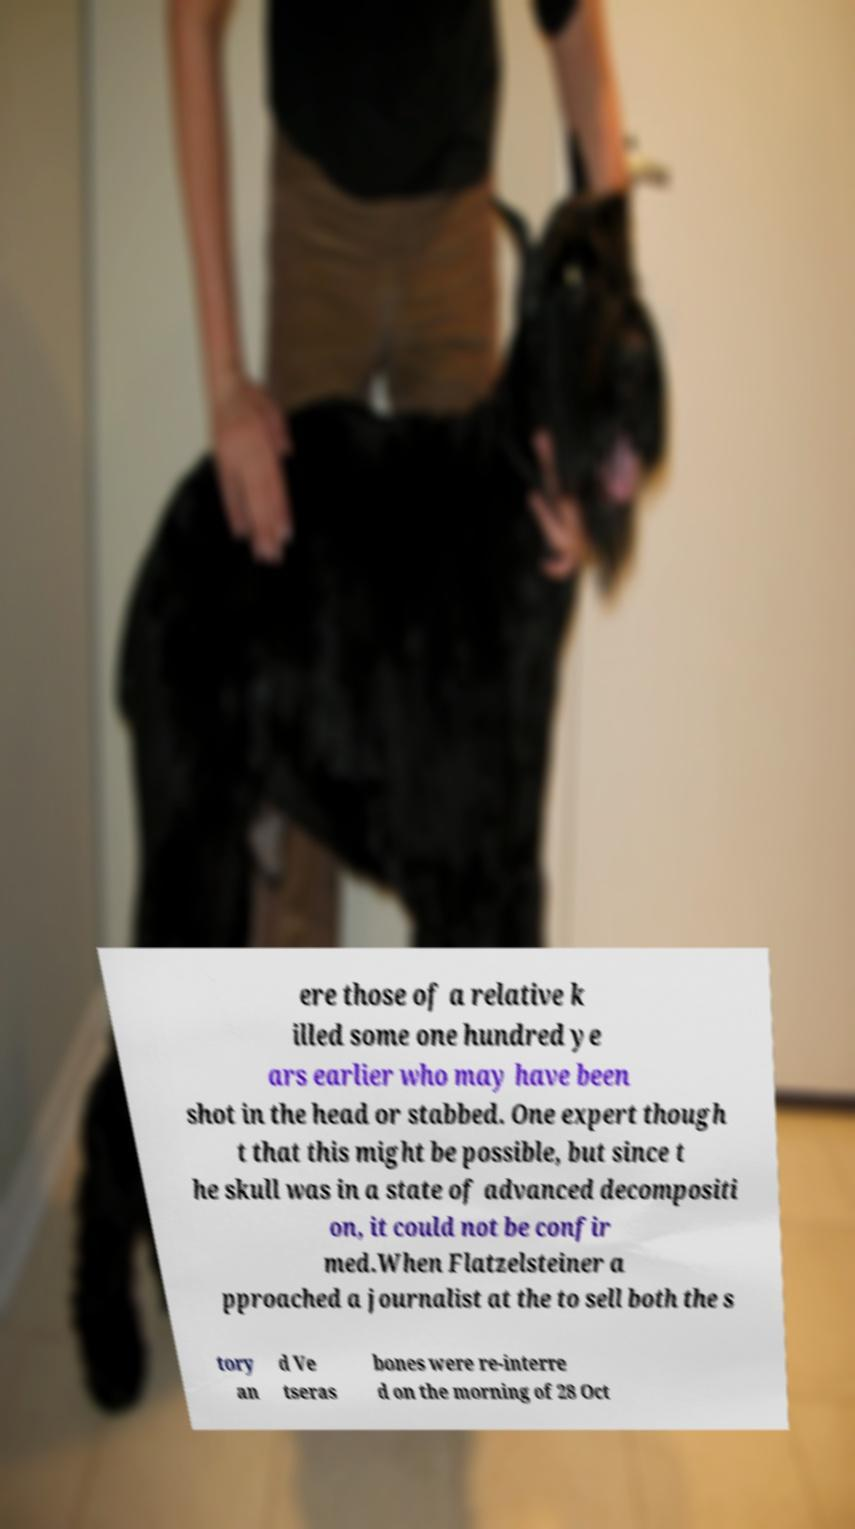Could you assist in decoding the text presented in this image and type it out clearly? ere those of a relative k illed some one hundred ye ars earlier who may have been shot in the head or stabbed. One expert though t that this might be possible, but since t he skull was in a state of advanced decompositi on, it could not be confir med.When Flatzelsteiner a pproached a journalist at the to sell both the s tory an d Ve tseras bones were re-interre d on the morning of 28 Oct 